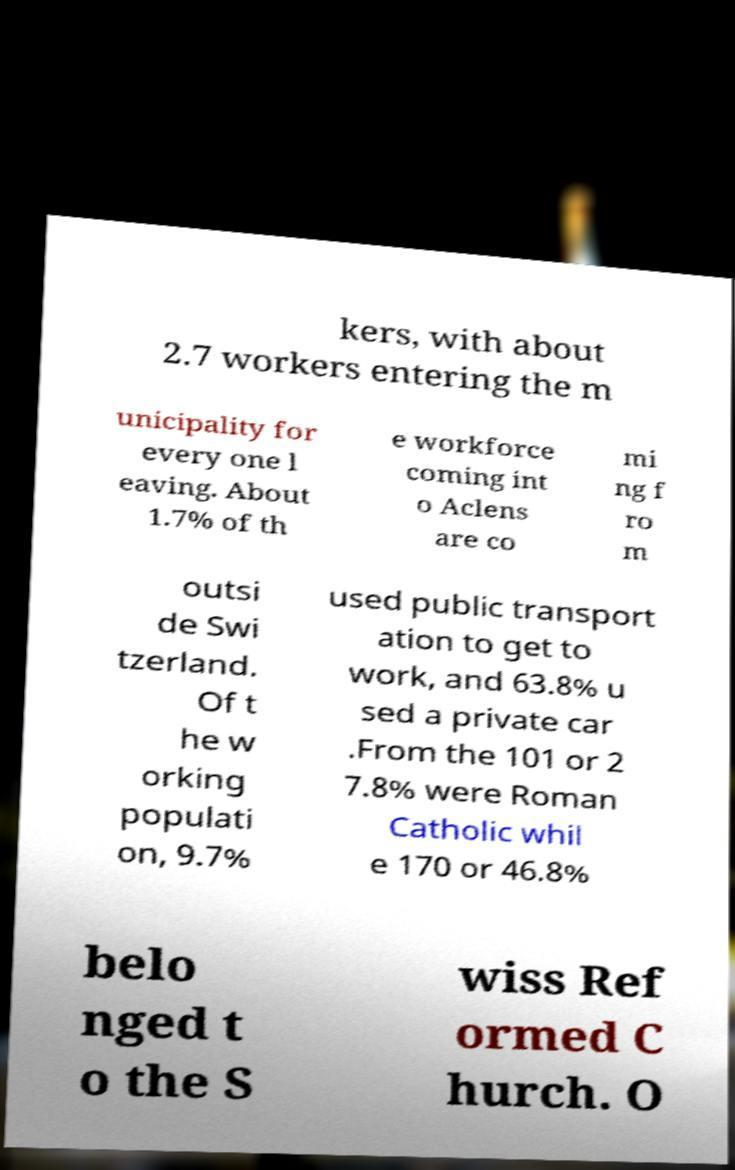I need the written content from this picture converted into text. Can you do that? kers, with about 2.7 workers entering the m unicipality for every one l eaving. About 1.7% of th e workforce coming int o Aclens are co mi ng f ro m outsi de Swi tzerland. Of t he w orking populati on, 9.7% used public transport ation to get to work, and 63.8% u sed a private car .From the 101 or 2 7.8% were Roman Catholic whil e 170 or 46.8% belo nged t o the S wiss Ref ormed C hurch. O 